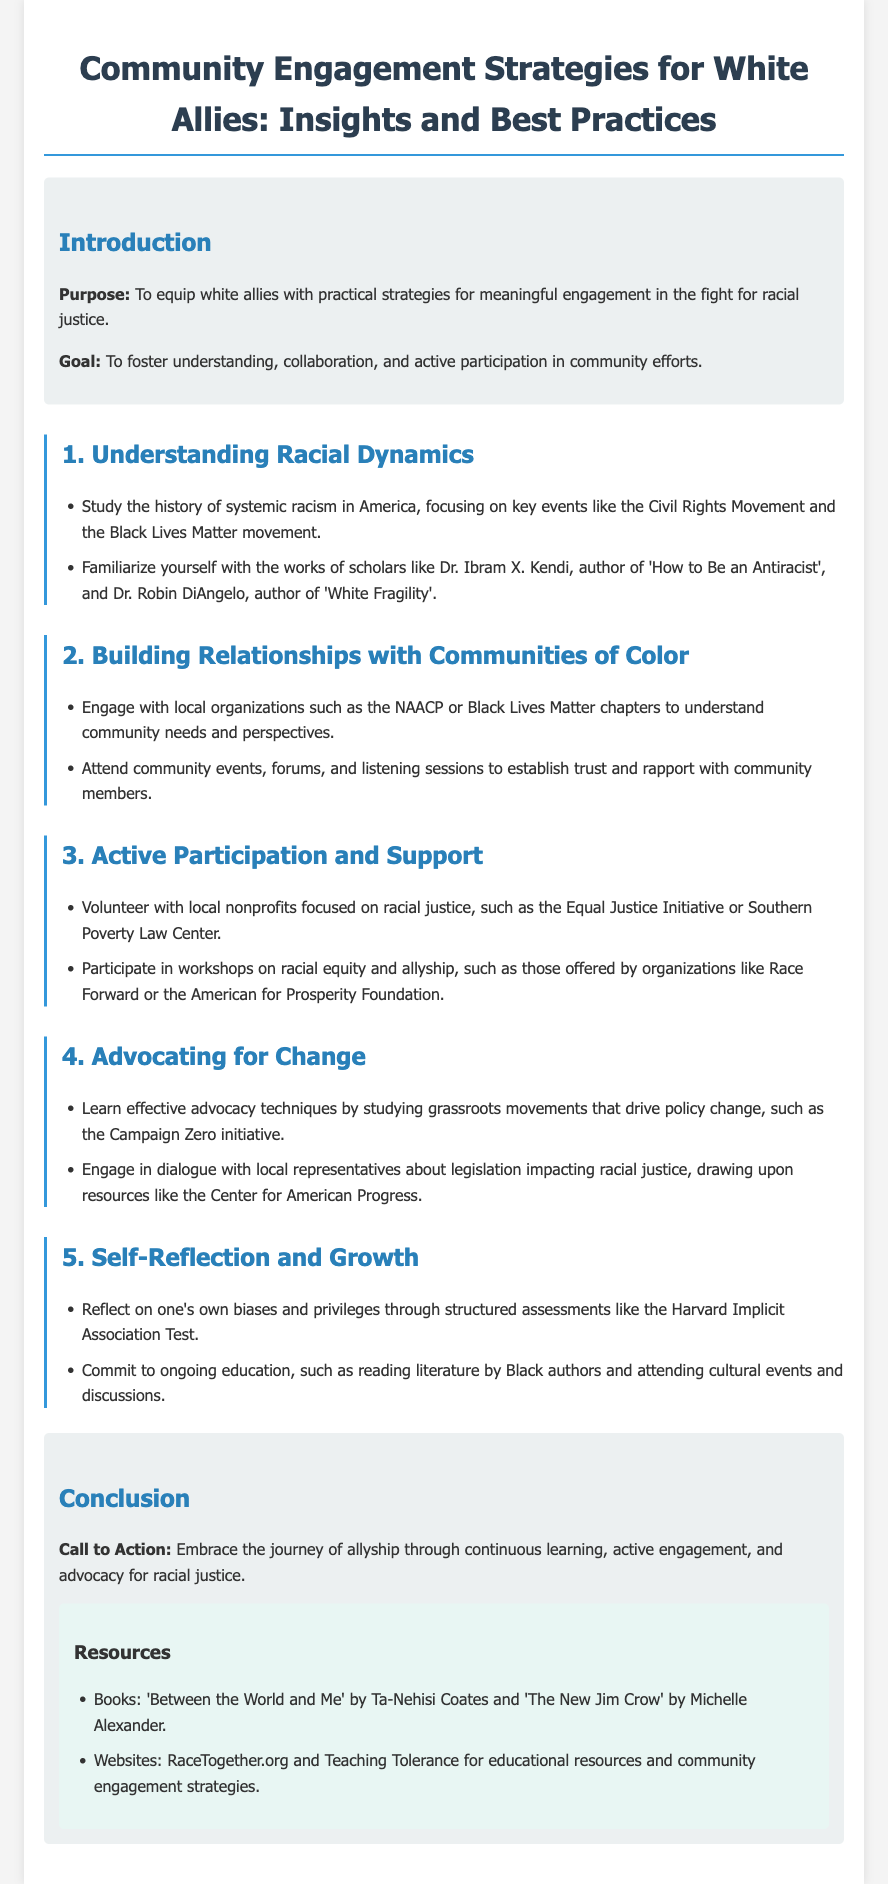what is the purpose of the document? The purpose is to equip white allies with practical strategies for meaningful engagement in the fight for racial justice.
Answer: to equip white allies with practical strategies for meaningful engagement in the fight for racial justice who is the author of 'How to Be an Antiracist'? This is information that specifies a key scholar whose work is recommended for understanding racial dynamics.
Answer: Dr. Ibram X. Kendi what organization is suggested for local engagement? This question addresses specific community organizations that can help white allies connect with communities of color.
Answer: NAACP what type of events should allies attend to build relationships? This is a retrieval question focusing on the recommended activities for establishing trust with community members.
Answer: community events, forums, and listening sessions which policy change technique is mentioned? This is asking for advocacy methods that white allies can study related to driving policy change.
Answer: grassroots movements what is a resource mentioned for ongoing education? The question seeks to identify specific literature or authors recommended for further learning about racial justice.
Answer: 'Between the World and Me' what does the document emphasize as important for self-reflection? This question quantifies the importance of understanding one's own biases in the allyship process.
Answer: Harvard Implicit Association Test how many main sections are there in this document? This question assesses the structure of the document by requiring a count of its main components.
Answer: five what is the call to action stated in the conclusion? This question captures the concluding urge directed towards the readers to engage in specific behaviors as allies.
Answer: Embrace the journey of allyship through continuous learning, active engagement, and advocacy for racial justice 